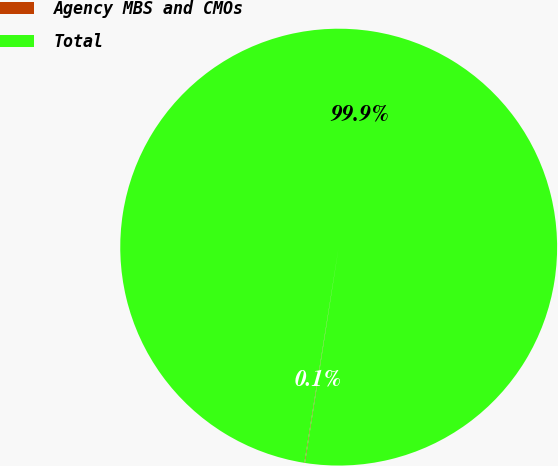<chart> <loc_0><loc_0><loc_500><loc_500><pie_chart><fcel>Agency MBS and CMOs<fcel>Total<nl><fcel>0.05%<fcel>99.95%<nl></chart> 